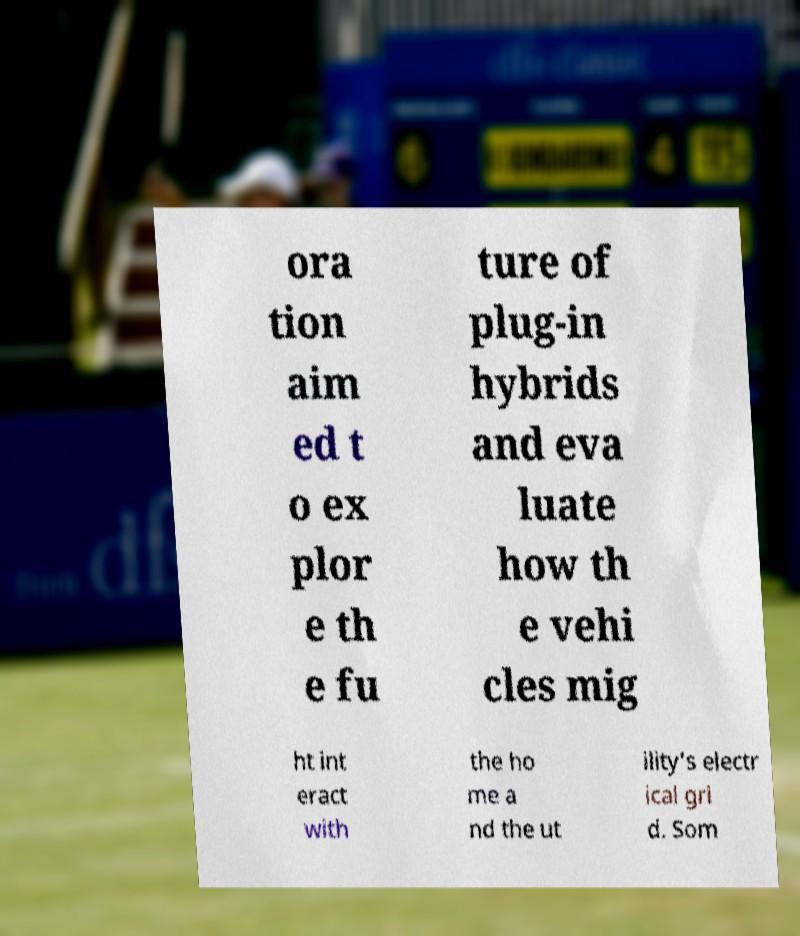Could you extract and type out the text from this image? ora tion aim ed t o ex plor e th e fu ture of plug-in hybrids and eva luate how th e vehi cles mig ht int eract with the ho me a nd the ut ility's electr ical gri d. Som 